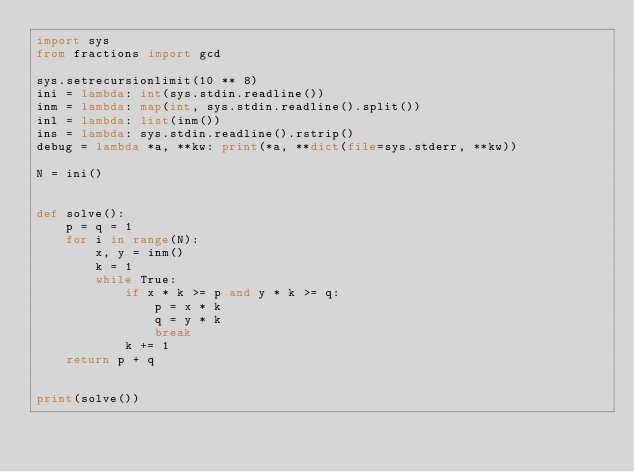Convert code to text. <code><loc_0><loc_0><loc_500><loc_500><_Python_>import sys
from fractions import gcd

sys.setrecursionlimit(10 ** 8)
ini = lambda: int(sys.stdin.readline())
inm = lambda: map(int, sys.stdin.readline().split())
inl = lambda: list(inm())
ins = lambda: sys.stdin.readline().rstrip()
debug = lambda *a, **kw: print(*a, **dict(file=sys.stderr, **kw))

N = ini()


def solve():
    p = q = 1
    for i in range(N):
        x, y = inm()
        k = 1
        while True:
            if x * k >= p and y * k >= q:
                p = x * k
                q = y * k
                break
            k += 1
    return p + q


print(solve())
</code> 